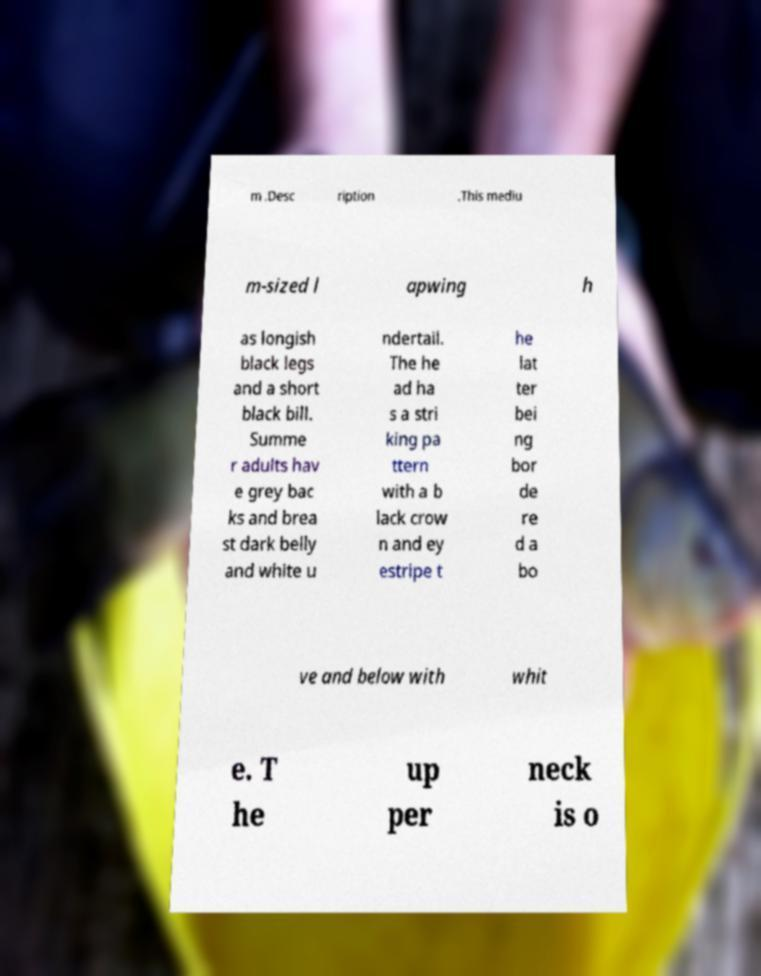For documentation purposes, I need the text within this image transcribed. Could you provide that? m .Desc ription .This mediu m-sized l apwing h as longish black legs and a short black bill. Summe r adults hav e grey bac ks and brea st dark belly and white u ndertail. The he ad ha s a stri king pa ttern with a b lack crow n and ey estripe t he lat ter bei ng bor de re d a bo ve and below with whit e. T he up per neck is o 